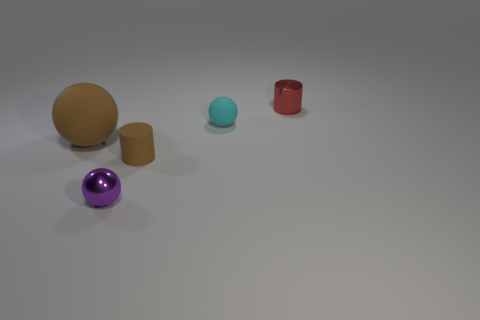Subtract all small matte spheres. How many spheres are left? 2 Add 2 cyan spheres. How many objects exist? 7 Subtract all brown cylinders. How many cylinders are left? 1 Subtract all balls. How many objects are left? 2 Subtract 1 spheres. How many spheres are left? 2 Subtract all purple cylinders. How many red balls are left? 0 Subtract all tiny brown metallic blocks. Subtract all big brown balls. How many objects are left? 4 Add 1 brown matte cylinders. How many brown matte cylinders are left? 2 Add 4 tiny brown cylinders. How many tiny brown cylinders exist? 5 Subtract 0 red cubes. How many objects are left? 5 